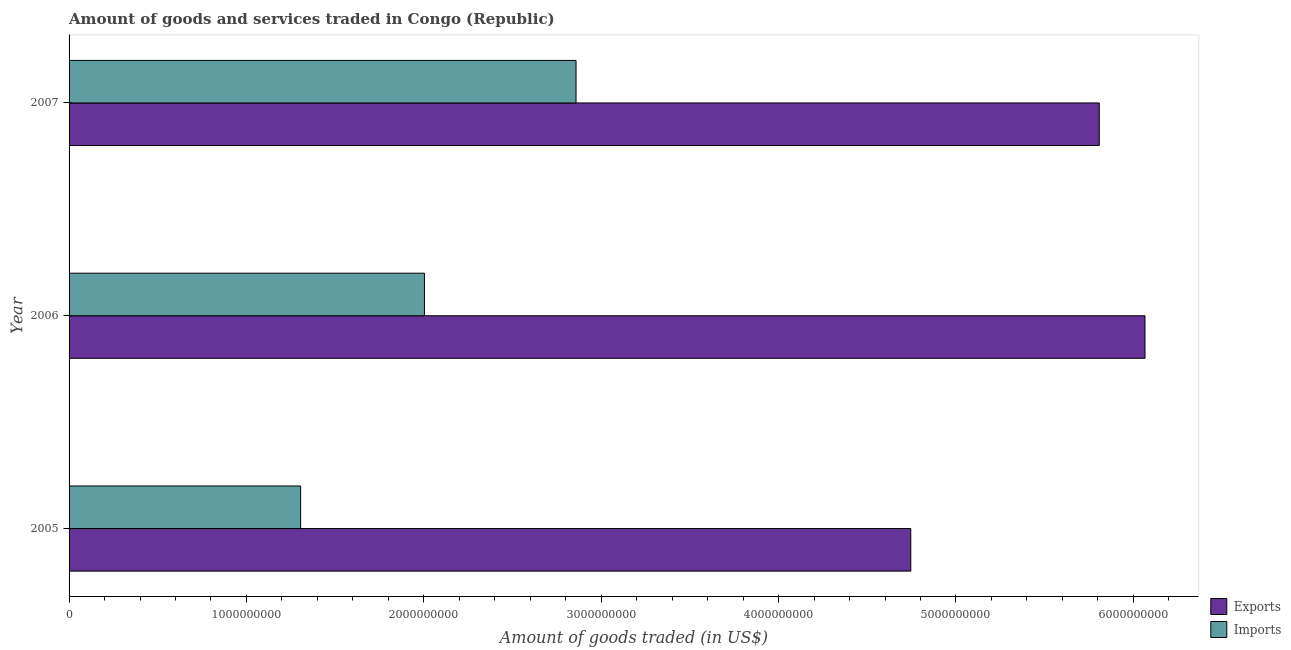How many bars are there on the 3rd tick from the top?
Give a very brief answer. 2. What is the label of the 3rd group of bars from the top?
Offer a very short reply. 2005. What is the amount of goods exported in 2005?
Ensure brevity in your answer.  4.75e+09. Across all years, what is the maximum amount of goods imported?
Keep it short and to the point. 2.86e+09. Across all years, what is the minimum amount of goods exported?
Your answer should be compact. 4.75e+09. What is the total amount of goods exported in the graph?
Offer a terse response. 1.66e+1. What is the difference between the amount of goods exported in 2005 and that in 2007?
Offer a very short reply. -1.06e+09. What is the difference between the amount of goods imported in 2007 and the amount of goods exported in 2005?
Provide a succinct answer. -1.89e+09. What is the average amount of goods exported per year?
Keep it short and to the point. 5.54e+09. In the year 2006, what is the difference between the amount of goods imported and amount of goods exported?
Provide a short and direct response. -4.06e+09. What is the ratio of the amount of goods exported in 2005 to that in 2006?
Ensure brevity in your answer.  0.78. What is the difference between the highest and the second highest amount of goods exported?
Provide a short and direct response. 2.58e+08. What is the difference between the highest and the lowest amount of goods imported?
Ensure brevity in your answer.  1.55e+09. Is the sum of the amount of goods exported in 2005 and 2006 greater than the maximum amount of goods imported across all years?
Give a very brief answer. Yes. What does the 2nd bar from the top in 2005 represents?
Make the answer very short. Exports. What does the 2nd bar from the bottom in 2006 represents?
Provide a succinct answer. Imports. How many years are there in the graph?
Your response must be concise. 3. Are the values on the major ticks of X-axis written in scientific E-notation?
Offer a very short reply. No. Does the graph contain grids?
Provide a succinct answer. No. How many legend labels are there?
Ensure brevity in your answer.  2. How are the legend labels stacked?
Your response must be concise. Vertical. What is the title of the graph?
Provide a succinct answer. Amount of goods and services traded in Congo (Republic). Does "Infant" appear as one of the legend labels in the graph?
Provide a succinct answer. No. What is the label or title of the X-axis?
Your answer should be compact. Amount of goods traded (in US$). What is the label or title of the Y-axis?
Keep it short and to the point. Year. What is the Amount of goods traded (in US$) in Exports in 2005?
Offer a very short reply. 4.75e+09. What is the Amount of goods traded (in US$) in Imports in 2005?
Ensure brevity in your answer.  1.31e+09. What is the Amount of goods traded (in US$) of Exports in 2006?
Keep it short and to the point. 6.07e+09. What is the Amount of goods traded (in US$) in Imports in 2006?
Ensure brevity in your answer.  2.00e+09. What is the Amount of goods traded (in US$) of Exports in 2007?
Your response must be concise. 5.81e+09. What is the Amount of goods traded (in US$) in Imports in 2007?
Your answer should be compact. 2.86e+09. Across all years, what is the maximum Amount of goods traded (in US$) of Exports?
Give a very brief answer. 6.07e+09. Across all years, what is the maximum Amount of goods traded (in US$) of Imports?
Make the answer very short. 2.86e+09. Across all years, what is the minimum Amount of goods traded (in US$) of Exports?
Your response must be concise. 4.75e+09. Across all years, what is the minimum Amount of goods traded (in US$) in Imports?
Make the answer very short. 1.31e+09. What is the total Amount of goods traded (in US$) in Exports in the graph?
Ensure brevity in your answer.  1.66e+1. What is the total Amount of goods traded (in US$) of Imports in the graph?
Offer a very short reply. 6.17e+09. What is the difference between the Amount of goods traded (in US$) in Exports in 2005 and that in 2006?
Your response must be concise. -1.32e+09. What is the difference between the Amount of goods traded (in US$) in Imports in 2005 and that in 2006?
Provide a succinct answer. -6.98e+08. What is the difference between the Amount of goods traded (in US$) in Exports in 2005 and that in 2007?
Offer a very short reply. -1.06e+09. What is the difference between the Amount of goods traded (in US$) in Imports in 2005 and that in 2007?
Offer a very short reply. -1.55e+09. What is the difference between the Amount of goods traded (in US$) in Exports in 2006 and that in 2007?
Your answer should be compact. 2.58e+08. What is the difference between the Amount of goods traded (in US$) of Imports in 2006 and that in 2007?
Your answer should be compact. -8.55e+08. What is the difference between the Amount of goods traded (in US$) of Exports in 2005 and the Amount of goods traded (in US$) of Imports in 2006?
Give a very brief answer. 2.74e+09. What is the difference between the Amount of goods traded (in US$) of Exports in 2005 and the Amount of goods traded (in US$) of Imports in 2007?
Keep it short and to the point. 1.89e+09. What is the difference between the Amount of goods traded (in US$) in Exports in 2006 and the Amount of goods traded (in US$) in Imports in 2007?
Keep it short and to the point. 3.21e+09. What is the average Amount of goods traded (in US$) in Exports per year?
Your response must be concise. 5.54e+09. What is the average Amount of goods traded (in US$) in Imports per year?
Ensure brevity in your answer.  2.06e+09. In the year 2005, what is the difference between the Amount of goods traded (in US$) of Exports and Amount of goods traded (in US$) of Imports?
Ensure brevity in your answer.  3.44e+09. In the year 2006, what is the difference between the Amount of goods traded (in US$) in Exports and Amount of goods traded (in US$) in Imports?
Give a very brief answer. 4.06e+09. In the year 2007, what is the difference between the Amount of goods traded (in US$) in Exports and Amount of goods traded (in US$) in Imports?
Your response must be concise. 2.95e+09. What is the ratio of the Amount of goods traded (in US$) of Exports in 2005 to that in 2006?
Make the answer very short. 0.78. What is the ratio of the Amount of goods traded (in US$) in Imports in 2005 to that in 2006?
Your answer should be very brief. 0.65. What is the ratio of the Amount of goods traded (in US$) in Exports in 2005 to that in 2007?
Offer a very short reply. 0.82. What is the ratio of the Amount of goods traded (in US$) in Imports in 2005 to that in 2007?
Offer a terse response. 0.46. What is the ratio of the Amount of goods traded (in US$) of Exports in 2006 to that in 2007?
Offer a terse response. 1.04. What is the ratio of the Amount of goods traded (in US$) in Imports in 2006 to that in 2007?
Keep it short and to the point. 0.7. What is the difference between the highest and the second highest Amount of goods traded (in US$) in Exports?
Provide a short and direct response. 2.58e+08. What is the difference between the highest and the second highest Amount of goods traded (in US$) in Imports?
Provide a short and direct response. 8.55e+08. What is the difference between the highest and the lowest Amount of goods traded (in US$) of Exports?
Your response must be concise. 1.32e+09. What is the difference between the highest and the lowest Amount of goods traded (in US$) in Imports?
Provide a short and direct response. 1.55e+09. 